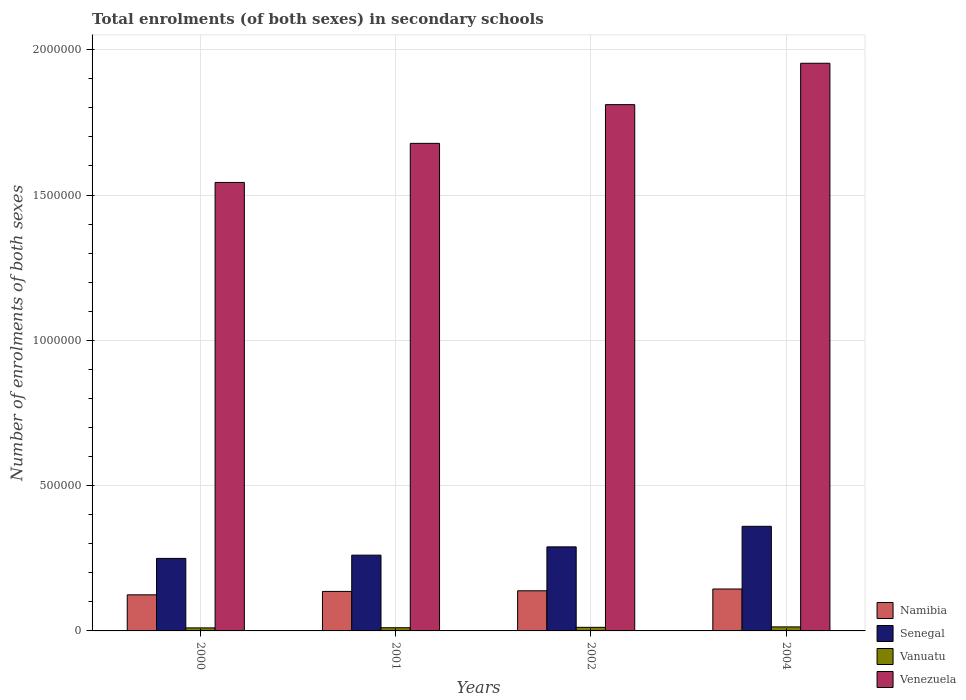How many different coloured bars are there?
Keep it short and to the point. 4. Are the number of bars per tick equal to the number of legend labels?
Provide a succinct answer. Yes. What is the number of enrolments in secondary schools in Senegal in 2002?
Provide a succinct answer. 2.89e+05. Across all years, what is the maximum number of enrolments in secondary schools in Venezuela?
Offer a very short reply. 1.95e+06. Across all years, what is the minimum number of enrolments in secondary schools in Venezuela?
Provide a short and direct response. 1.54e+06. What is the total number of enrolments in secondary schools in Senegal in the graph?
Provide a succinct answer. 1.16e+06. What is the difference between the number of enrolments in secondary schools in Namibia in 2002 and that in 2004?
Provide a succinct answer. -6190. What is the difference between the number of enrolments in secondary schools in Namibia in 2002 and the number of enrolments in secondary schools in Vanuatu in 2004?
Make the answer very short. 1.24e+05. What is the average number of enrolments in secondary schools in Senegal per year?
Your answer should be compact. 2.90e+05. In the year 2000, what is the difference between the number of enrolments in secondary schools in Senegal and number of enrolments in secondary schools in Vanuatu?
Your response must be concise. 2.39e+05. In how many years, is the number of enrolments in secondary schools in Namibia greater than 1500000?
Provide a succinct answer. 0. What is the ratio of the number of enrolments in secondary schools in Vanuatu in 2001 to that in 2004?
Your answer should be compact. 0.79. Is the number of enrolments in secondary schools in Namibia in 2001 less than that in 2004?
Your answer should be compact. Yes. Is the difference between the number of enrolments in secondary schools in Senegal in 2000 and 2001 greater than the difference between the number of enrolments in secondary schools in Vanuatu in 2000 and 2001?
Your answer should be compact. No. What is the difference between the highest and the second highest number of enrolments in secondary schools in Vanuatu?
Offer a terse response. 1524. What is the difference between the highest and the lowest number of enrolments in secondary schools in Senegal?
Provide a succinct answer. 1.10e+05. Is it the case that in every year, the sum of the number of enrolments in secondary schools in Vanuatu and number of enrolments in secondary schools in Venezuela is greater than the sum of number of enrolments in secondary schools in Senegal and number of enrolments in secondary schools in Namibia?
Provide a succinct answer. Yes. What does the 2nd bar from the left in 2002 represents?
Your answer should be compact. Senegal. What does the 3rd bar from the right in 2004 represents?
Keep it short and to the point. Senegal. Is it the case that in every year, the sum of the number of enrolments in secondary schools in Namibia and number of enrolments in secondary schools in Venezuela is greater than the number of enrolments in secondary schools in Vanuatu?
Your answer should be compact. Yes. How many bars are there?
Your response must be concise. 16. Are all the bars in the graph horizontal?
Provide a short and direct response. No. How many years are there in the graph?
Make the answer very short. 4. Where does the legend appear in the graph?
Give a very brief answer. Bottom right. What is the title of the graph?
Your answer should be very brief. Total enrolments (of both sexes) in secondary schools. What is the label or title of the X-axis?
Provide a succinct answer. Years. What is the label or title of the Y-axis?
Offer a very short reply. Number of enrolments of both sexes. What is the Number of enrolments of both sexes in Namibia in 2000?
Give a very brief answer. 1.24e+05. What is the Number of enrolments of both sexes in Senegal in 2000?
Give a very brief answer. 2.50e+05. What is the Number of enrolments of both sexes of Vanuatu in 2000?
Ensure brevity in your answer.  1.04e+04. What is the Number of enrolments of both sexes of Venezuela in 2000?
Keep it short and to the point. 1.54e+06. What is the Number of enrolments of both sexes in Namibia in 2001?
Offer a very short reply. 1.36e+05. What is the Number of enrolments of both sexes of Senegal in 2001?
Your answer should be very brief. 2.61e+05. What is the Number of enrolments of both sexes of Vanuatu in 2001?
Your response must be concise. 1.09e+04. What is the Number of enrolments of both sexes in Venezuela in 2001?
Your answer should be compact. 1.68e+06. What is the Number of enrolments of both sexes of Namibia in 2002?
Ensure brevity in your answer.  1.38e+05. What is the Number of enrolments of both sexes of Senegal in 2002?
Your response must be concise. 2.89e+05. What is the Number of enrolments of both sexes of Vanuatu in 2002?
Make the answer very short. 1.23e+04. What is the Number of enrolments of both sexes in Venezuela in 2002?
Keep it short and to the point. 1.81e+06. What is the Number of enrolments of both sexes in Namibia in 2004?
Offer a very short reply. 1.44e+05. What is the Number of enrolments of both sexes of Senegal in 2004?
Give a very brief answer. 3.60e+05. What is the Number of enrolments of both sexes of Vanuatu in 2004?
Offer a very short reply. 1.38e+04. What is the Number of enrolments of both sexes in Venezuela in 2004?
Make the answer very short. 1.95e+06. Across all years, what is the maximum Number of enrolments of both sexes of Namibia?
Ensure brevity in your answer.  1.44e+05. Across all years, what is the maximum Number of enrolments of both sexes in Senegal?
Provide a short and direct response. 3.60e+05. Across all years, what is the maximum Number of enrolments of both sexes of Vanuatu?
Give a very brief answer. 1.38e+04. Across all years, what is the maximum Number of enrolments of both sexes of Venezuela?
Keep it short and to the point. 1.95e+06. Across all years, what is the minimum Number of enrolments of both sexes of Namibia?
Provide a short and direct response. 1.24e+05. Across all years, what is the minimum Number of enrolments of both sexes of Senegal?
Offer a terse response. 2.50e+05. Across all years, what is the minimum Number of enrolments of both sexes of Vanuatu?
Provide a short and direct response. 1.04e+04. Across all years, what is the minimum Number of enrolments of both sexes in Venezuela?
Ensure brevity in your answer.  1.54e+06. What is the total Number of enrolments of both sexes in Namibia in the graph?
Provide a succinct answer. 5.43e+05. What is the total Number of enrolments of both sexes in Senegal in the graph?
Ensure brevity in your answer.  1.16e+06. What is the total Number of enrolments of both sexes of Vanuatu in the graph?
Offer a very short reply. 4.75e+04. What is the total Number of enrolments of both sexes of Venezuela in the graph?
Your answer should be compact. 6.99e+06. What is the difference between the Number of enrolments of both sexes in Namibia in 2000 and that in 2001?
Give a very brief answer. -1.17e+04. What is the difference between the Number of enrolments of both sexes in Senegal in 2000 and that in 2001?
Offer a very short reply. -1.12e+04. What is the difference between the Number of enrolments of both sexes in Vanuatu in 2000 and that in 2001?
Your response must be concise. -488. What is the difference between the Number of enrolments of both sexes in Venezuela in 2000 and that in 2001?
Make the answer very short. -1.34e+05. What is the difference between the Number of enrolments of both sexes in Namibia in 2000 and that in 2002?
Your answer should be compact. -1.39e+04. What is the difference between the Number of enrolments of both sexes of Senegal in 2000 and that in 2002?
Offer a very short reply. -3.97e+04. What is the difference between the Number of enrolments of both sexes in Vanuatu in 2000 and that in 2002?
Make the answer very short. -1867. What is the difference between the Number of enrolments of both sexes in Venezuela in 2000 and that in 2002?
Your answer should be compact. -2.68e+05. What is the difference between the Number of enrolments of both sexes in Namibia in 2000 and that in 2004?
Provide a short and direct response. -2.01e+04. What is the difference between the Number of enrolments of both sexes of Senegal in 2000 and that in 2004?
Provide a short and direct response. -1.10e+05. What is the difference between the Number of enrolments of both sexes in Vanuatu in 2000 and that in 2004?
Make the answer very short. -3391. What is the difference between the Number of enrolments of both sexes of Venezuela in 2000 and that in 2004?
Offer a terse response. -4.10e+05. What is the difference between the Number of enrolments of both sexes of Namibia in 2001 and that in 2002?
Offer a terse response. -2156. What is the difference between the Number of enrolments of both sexes in Senegal in 2001 and that in 2002?
Keep it short and to the point. -2.85e+04. What is the difference between the Number of enrolments of both sexes in Vanuatu in 2001 and that in 2002?
Your answer should be compact. -1379. What is the difference between the Number of enrolments of both sexes of Venezuela in 2001 and that in 2002?
Offer a very short reply. -1.33e+05. What is the difference between the Number of enrolments of both sexes in Namibia in 2001 and that in 2004?
Provide a succinct answer. -8346. What is the difference between the Number of enrolments of both sexes in Senegal in 2001 and that in 2004?
Provide a succinct answer. -9.93e+04. What is the difference between the Number of enrolments of both sexes in Vanuatu in 2001 and that in 2004?
Offer a terse response. -2903. What is the difference between the Number of enrolments of both sexes in Venezuela in 2001 and that in 2004?
Offer a very short reply. -2.76e+05. What is the difference between the Number of enrolments of both sexes in Namibia in 2002 and that in 2004?
Give a very brief answer. -6190. What is the difference between the Number of enrolments of both sexes of Senegal in 2002 and that in 2004?
Your answer should be compact. -7.08e+04. What is the difference between the Number of enrolments of both sexes of Vanuatu in 2002 and that in 2004?
Your response must be concise. -1524. What is the difference between the Number of enrolments of both sexes of Venezuela in 2002 and that in 2004?
Make the answer very short. -1.42e+05. What is the difference between the Number of enrolments of both sexes in Namibia in 2000 and the Number of enrolments of both sexes in Senegal in 2001?
Offer a terse response. -1.37e+05. What is the difference between the Number of enrolments of both sexes in Namibia in 2000 and the Number of enrolments of both sexes in Vanuatu in 2001?
Provide a short and direct response. 1.13e+05. What is the difference between the Number of enrolments of both sexes in Namibia in 2000 and the Number of enrolments of both sexes in Venezuela in 2001?
Ensure brevity in your answer.  -1.55e+06. What is the difference between the Number of enrolments of both sexes in Senegal in 2000 and the Number of enrolments of both sexes in Vanuatu in 2001?
Ensure brevity in your answer.  2.39e+05. What is the difference between the Number of enrolments of both sexes in Senegal in 2000 and the Number of enrolments of both sexes in Venezuela in 2001?
Your answer should be very brief. -1.43e+06. What is the difference between the Number of enrolments of both sexes in Vanuatu in 2000 and the Number of enrolments of both sexes in Venezuela in 2001?
Your answer should be very brief. -1.67e+06. What is the difference between the Number of enrolments of both sexes in Namibia in 2000 and the Number of enrolments of both sexes in Senegal in 2002?
Provide a short and direct response. -1.65e+05. What is the difference between the Number of enrolments of both sexes in Namibia in 2000 and the Number of enrolments of both sexes in Vanuatu in 2002?
Offer a very short reply. 1.12e+05. What is the difference between the Number of enrolments of both sexes of Namibia in 2000 and the Number of enrolments of both sexes of Venezuela in 2002?
Keep it short and to the point. -1.69e+06. What is the difference between the Number of enrolments of both sexes of Senegal in 2000 and the Number of enrolments of both sexes of Vanuatu in 2002?
Keep it short and to the point. 2.37e+05. What is the difference between the Number of enrolments of both sexes in Senegal in 2000 and the Number of enrolments of both sexes in Venezuela in 2002?
Make the answer very short. -1.56e+06. What is the difference between the Number of enrolments of both sexes of Vanuatu in 2000 and the Number of enrolments of both sexes of Venezuela in 2002?
Ensure brevity in your answer.  -1.80e+06. What is the difference between the Number of enrolments of both sexes of Namibia in 2000 and the Number of enrolments of both sexes of Senegal in 2004?
Ensure brevity in your answer.  -2.36e+05. What is the difference between the Number of enrolments of both sexes of Namibia in 2000 and the Number of enrolments of both sexes of Vanuatu in 2004?
Ensure brevity in your answer.  1.10e+05. What is the difference between the Number of enrolments of both sexes in Namibia in 2000 and the Number of enrolments of both sexes in Venezuela in 2004?
Keep it short and to the point. -1.83e+06. What is the difference between the Number of enrolments of both sexes of Senegal in 2000 and the Number of enrolments of both sexes of Vanuatu in 2004?
Offer a very short reply. 2.36e+05. What is the difference between the Number of enrolments of both sexes in Senegal in 2000 and the Number of enrolments of both sexes in Venezuela in 2004?
Ensure brevity in your answer.  -1.70e+06. What is the difference between the Number of enrolments of both sexes in Vanuatu in 2000 and the Number of enrolments of both sexes in Venezuela in 2004?
Keep it short and to the point. -1.94e+06. What is the difference between the Number of enrolments of both sexes in Namibia in 2001 and the Number of enrolments of both sexes in Senegal in 2002?
Your answer should be very brief. -1.53e+05. What is the difference between the Number of enrolments of both sexes in Namibia in 2001 and the Number of enrolments of both sexes in Vanuatu in 2002?
Your answer should be very brief. 1.24e+05. What is the difference between the Number of enrolments of both sexes in Namibia in 2001 and the Number of enrolments of both sexes in Venezuela in 2002?
Your answer should be compact. -1.68e+06. What is the difference between the Number of enrolments of both sexes in Senegal in 2001 and the Number of enrolments of both sexes in Vanuatu in 2002?
Give a very brief answer. 2.48e+05. What is the difference between the Number of enrolments of both sexes in Senegal in 2001 and the Number of enrolments of both sexes in Venezuela in 2002?
Offer a terse response. -1.55e+06. What is the difference between the Number of enrolments of both sexes of Vanuatu in 2001 and the Number of enrolments of both sexes of Venezuela in 2002?
Give a very brief answer. -1.80e+06. What is the difference between the Number of enrolments of both sexes in Namibia in 2001 and the Number of enrolments of both sexes in Senegal in 2004?
Your answer should be very brief. -2.24e+05. What is the difference between the Number of enrolments of both sexes in Namibia in 2001 and the Number of enrolments of both sexes in Vanuatu in 2004?
Provide a succinct answer. 1.22e+05. What is the difference between the Number of enrolments of both sexes of Namibia in 2001 and the Number of enrolments of both sexes of Venezuela in 2004?
Make the answer very short. -1.82e+06. What is the difference between the Number of enrolments of both sexes of Senegal in 2001 and the Number of enrolments of both sexes of Vanuatu in 2004?
Provide a succinct answer. 2.47e+05. What is the difference between the Number of enrolments of both sexes in Senegal in 2001 and the Number of enrolments of both sexes in Venezuela in 2004?
Make the answer very short. -1.69e+06. What is the difference between the Number of enrolments of both sexes of Vanuatu in 2001 and the Number of enrolments of both sexes of Venezuela in 2004?
Keep it short and to the point. -1.94e+06. What is the difference between the Number of enrolments of both sexes of Namibia in 2002 and the Number of enrolments of both sexes of Senegal in 2004?
Give a very brief answer. -2.22e+05. What is the difference between the Number of enrolments of both sexes of Namibia in 2002 and the Number of enrolments of both sexes of Vanuatu in 2004?
Your answer should be compact. 1.24e+05. What is the difference between the Number of enrolments of both sexes of Namibia in 2002 and the Number of enrolments of both sexes of Venezuela in 2004?
Offer a terse response. -1.82e+06. What is the difference between the Number of enrolments of both sexes in Senegal in 2002 and the Number of enrolments of both sexes in Vanuatu in 2004?
Make the answer very short. 2.75e+05. What is the difference between the Number of enrolments of both sexes in Senegal in 2002 and the Number of enrolments of both sexes in Venezuela in 2004?
Provide a short and direct response. -1.66e+06. What is the difference between the Number of enrolments of both sexes of Vanuatu in 2002 and the Number of enrolments of both sexes of Venezuela in 2004?
Your answer should be very brief. -1.94e+06. What is the average Number of enrolments of both sexes of Namibia per year?
Offer a very short reply. 1.36e+05. What is the average Number of enrolments of both sexes of Senegal per year?
Make the answer very short. 2.90e+05. What is the average Number of enrolments of both sexes in Vanuatu per year?
Offer a very short reply. 1.19e+04. What is the average Number of enrolments of both sexes of Venezuela per year?
Give a very brief answer. 1.75e+06. In the year 2000, what is the difference between the Number of enrolments of both sexes of Namibia and Number of enrolments of both sexes of Senegal?
Provide a succinct answer. -1.25e+05. In the year 2000, what is the difference between the Number of enrolments of both sexes of Namibia and Number of enrolments of both sexes of Vanuatu?
Your answer should be very brief. 1.14e+05. In the year 2000, what is the difference between the Number of enrolments of both sexes of Namibia and Number of enrolments of both sexes of Venezuela?
Your answer should be compact. -1.42e+06. In the year 2000, what is the difference between the Number of enrolments of both sexes in Senegal and Number of enrolments of both sexes in Vanuatu?
Provide a succinct answer. 2.39e+05. In the year 2000, what is the difference between the Number of enrolments of both sexes of Senegal and Number of enrolments of both sexes of Venezuela?
Keep it short and to the point. -1.29e+06. In the year 2000, what is the difference between the Number of enrolments of both sexes of Vanuatu and Number of enrolments of both sexes of Venezuela?
Ensure brevity in your answer.  -1.53e+06. In the year 2001, what is the difference between the Number of enrolments of both sexes in Namibia and Number of enrolments of both sexes in Senegal?
Offer a very short reply. -1.25e+05. In the year 2001, what is the difference between the Number of enrolments of both sexes of Namibia and Number of enrolments of both sexes of Vanuatu?
Offer a very short reply. 1.25e+05. In the year 2001, what is the difference between the Number of enrolments of both sexes in Namibia and Number of enrolments of both sexes in Venezuela?
Make the answer very short. -1.54e+06. In the year 2001, what is the difference between the Number of enrolments of both sexes in Senegal and Number of enrolments of both sexes in Vanuatu?
Ensure brevity in your answer.  2.50e+05. In the year 2001, what is the difference between the Number of enrolments of both sexes in Senegal and Number of enrolments of both sexes in Venezuela?
Keep it short and to the point. -1.42e+06. In the year 2001, what is the difference between the Number of enrolments of both sexes in Vanuatu and Number of enrolments of both sexes in Venezuela?
Your answer should be compact. -1.67e+06. In the year 2002, what is the difference between the Number of enrolments of both sexes of Namibia and Number of enrolments of both sexes of Senegal?
Give a very brief answer. -1.51e+05. In the year 2002, what is the difference between the Number of enrolments of both sexes in Namibia and Number of enrolments of both sexes in Vanuatu?
Your answer should be compact. 1.26e+05. In the year 2002, what is the difference between the Number of enrolments of both sexes in Namibia and Number of enrolments of both sexes in Venezuela?
Offer a very short reply. -1.67e+06. In the year 2002, what is the difference between the Number of enrolments of both sexes of Senegal and Number of enrolments of both sexes of Vanuatu?
Provide a succinct answer. 2.77e+05. In the year 2002, what is the difference between the Number of enrolments of both sexes in Senegal and Number of enrolments of both sexes in Venezuela?
Offer a very short reply. -1.52e+06. In the year 2002, what is the difference between the Number of enrolments of both sexes of Vanuatu and Number of enrolments of both sexes of Venezuela?
Provide a succinct answer. -1.80e+06. In the year 2004, what is the difference between the Number of enrolments of both sexes of Namibia and Number of enrolments of both sexes of Senegal?
Your response must be concise. -2.16e+05. In the year 2004, what is the difference between the Number of enrolments of both sexes in Namibia and Number of enrolments of both sexes in Vanuatu?
Offer a very short reply. 1.30e+05. In the year 2004, what is the difference between the Number of enrolments of both sexes of Namibia and Number of enrolments of both sexes of Venezuela?
Give a very brief answer. -1.81e+06. In the year 2004, what is the difference between the Number of enrolments of both sexes in Senegal and Number of enrolments of both sexes in Vanuatu?
Provide a short and direct response. 3.46e+05. In the year 2004, what is the difference between the Number of enrolments of both sexes in Senegal and Number of enrolments of both sexes in Venezuela?
Ensure brevity in your answer.  -1.59e+06. In the year 2004, what is the difference between the Number of enrolments of both sexes of Vanuatu and Number of enrolments of both sexes of Venezuela?
Offer a very short reply. -1.94e+06. What is the ratio of the Number of enrolments of both sexes of Namibia in 2000 to that in 2001?
Ensure brevity in your answer.  0.91. What is the ratio of the Number of enrolments of both sexes in Senegal in 2000 to that in 2001?
Offer a terse response. 0.96. What is the ratio of the Number of enrolments of both sexes of Vanuatu in 2000 to that in 2001?
Your answer should be compact. 0.96. What is the ratio of the Number of enrolments of both sexes in Venezuela in 2000 to that in 2001?
Make the answer very short. 0.92. What is the ratio of the Number of enrolments of both sexes of Namibia in 2000 to that in 2002?
Offer a very short reply. 0.9. What is the ratio of the Number of enrolments of both sexes in Senegal in 2000 to that in 2002?
Make the answer very short. 0.86. What is the ratio of the Number of enrolments of both sexes in Vanuatu in 2000 to that in 2002?
Your answer should be compact. 0.85. What is the ratio of the Number of enrolments of both sexes of Venezuela in 2000 to that in 2002?
Your answer should be very brief. 0.85. What is the ratio of the Number of enrolments of both sexes in Namibia in 2000 to that in 2004?
Your answer should be very brief. 0.86. What is the ratio of the Number of enrolments of both sexes of Senegal in 2000 to that in 2004?
Keep it short and to the point. 0.69. What is the ratio of the Number of enrolments of both sexes of Vanuatu in 2000 to that in 2004?
Provide a short and direct response. 0.75. What is the ratio of the Number of enrolments of both sexes of Venezuela in 2000 to that in 2004?
Provide a short and direct response. 0.79. What is the ratio of the Number of enrolments of both sexes in Namibia in 2001 to that in 2002?
Provide a succinct answer. 0.98. What is the ratio of the Number of enrolments of both sexes in Senegal in 2001 to that in 2002?
Provide a short and direct response. 0.9. What is the ratio of the Number of enrolments of both sexes of Vanuatu in 2001 to that in 2002?
Ensure brevity in your answer.  0.89. What is the ratio of the Number of enrolments of both sexes of Venezuela in 2001 to that in 2002?
Offer a terse response. 0.93. What is the ratio of the Number of enrolments of both sexes in Namibia in 2001 to that in 2004?
Provide a succinct answer. 0.94. What is the ratio of the Number of enrolments of both sexes of Senegal in 2001 to that in 2004?
Give a very brief answer. 0.72. What is the ratio of the Number of enrolments of both sexes of Vanuatu in 2001 to that in 2004?
Make the answer very short. 0.79. What is the ratio of the Number of enrolments of both sexes of Venezuela in 2001 to that in 2004?
Make the answer very short. 0.86. What is the ratio of the Number of enrolments of both sexes in Namibia in 2002 to that in 2004?
Your answer should be very brief. 0.96. What is the ratio of the Number of enrolments of both sexes in Senegal in 2002 to that in 2004?
Keep it short and to the point. 0.8. What is the ratio of the Number of enrolments of both sexes of Vanuatu in 2002 to that in 2004?
Make the answer very short. 0.89. What is the ratio of the Number of enrolments of both sexes in Venezuela in 2002 to that in 2004?
Ensure brevity in your answer.  0.93. What is the difference between the highest and the second highest Number of enrolments of both sexes of Namibia?
Your answer should be very brief. 6190. What is the difference between the highest and the second highest Number of enrolments of both sexes of Senegal?
Keep it short and to the point. 7.08e+04. What is the difference between the highest and the second highest Number of enrolments of both sexes of Vanuatu?
Ensure brevity in your answer.  1524. What is the difference between the highest and the second highest Number of enrolments of both sexes in Venezuela?
Provide a short and direct response. 1.42e+05. What is the difference between the highest and the lowest Number of enrolments of both sexes in Namibia?
Provide a short and direct response. 2.01e+04. What is the difference between the highest and the lowest Number of enrolments of both sexes of Senegal?
Your answer should be compact. 1.10e+05. What is the difference between the highest and the lowest Number of enrolments of both sexes of Vanuatu?
Provide a short and direct response. 3391. What is the difference between the highest and the lowest Number of enrolments of both sexes in Venezuela?
Provide a succinct answer. 4.10e+05. 